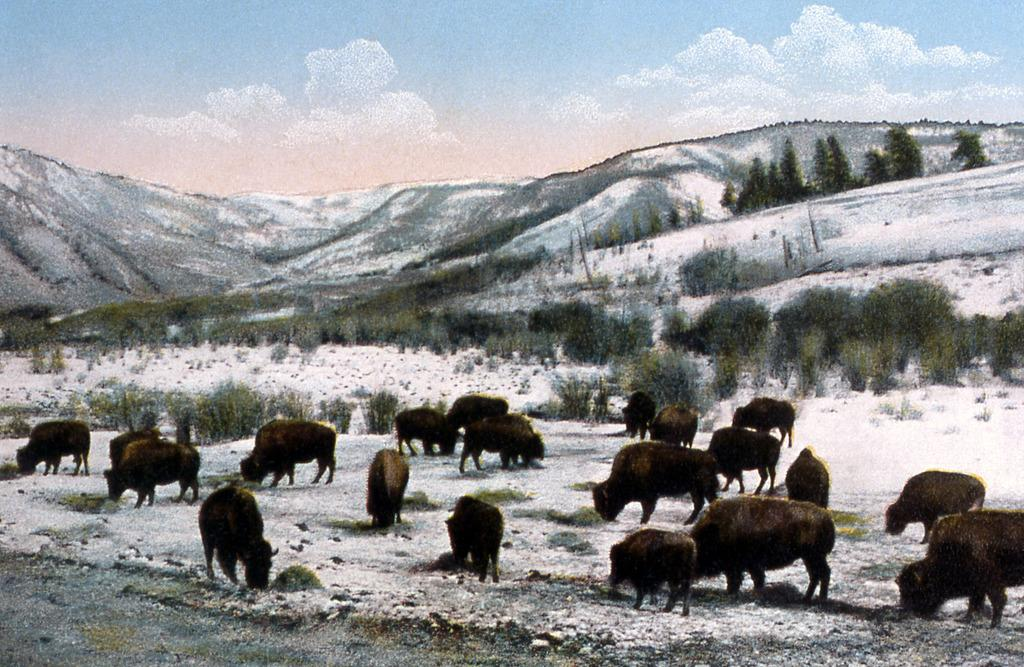What is the main subject of the image? The image contains a painting. What types of living organisms are depicted in the painting? There are animals in the painting. What natural elements are present in the painting? There are trees and hills in the painting. What is the condition of the sky in the painting? The sky in the painting is cloudy. What type of baseball equipment can be seen in the painting? There is no baseball equipment present in the painting; it features animals, trees, hills, and a cloudy sky. Can you describe the train that is passing through the border in the painting? There is no train or border present in the painting; it only contains a painting with animals, trees, hills, and a cloudy sky. 